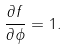Convert formula to latex. <formula><loc_0><loc_0><loc_500><loc_500>\frac { \partial f } { \partial \phi } = 1 .</formula> 